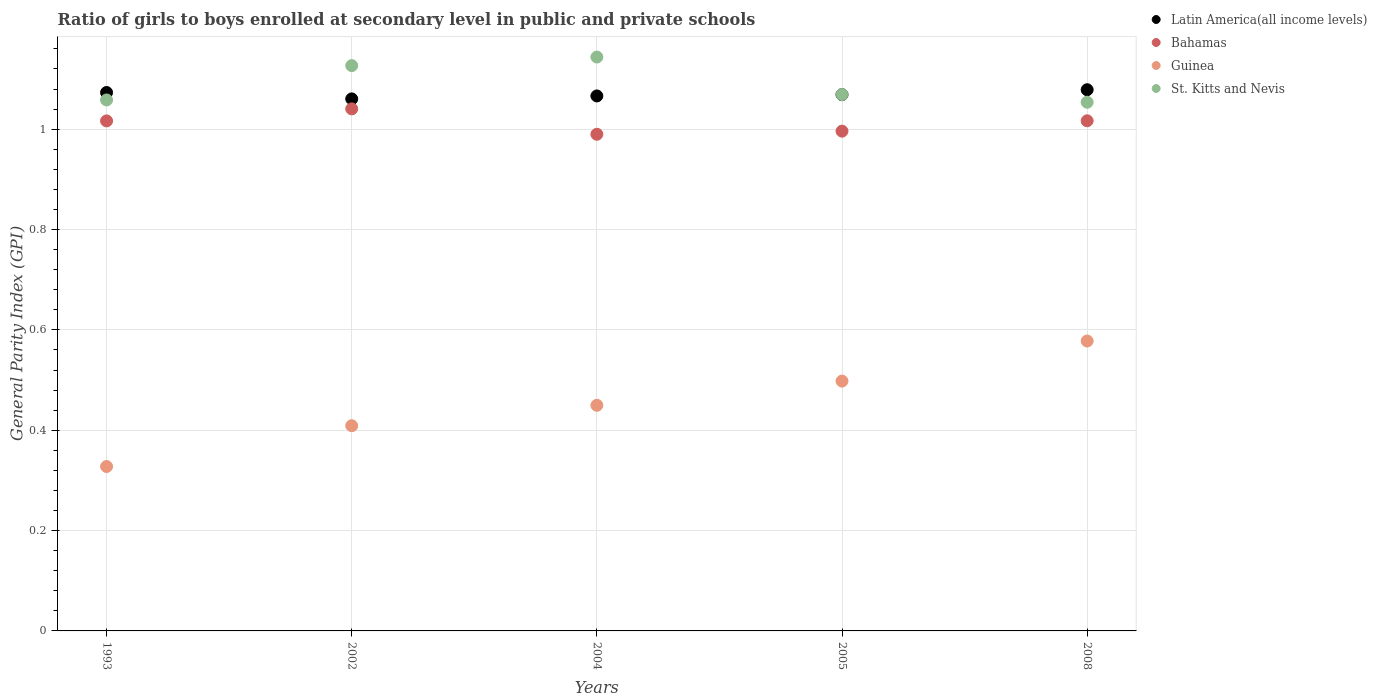How many different coloured dotlines are there?
Provide a succinct answer. 4. What is the general parity index in Latin America(all income levels) in 1993?
Provide a succinct answer. 1.07. Across all years, what is the maximum general parity index in St. Kitts and Nevis?
Give a very brief answer. 1.14. Across all years, what is the minimum general parity index in Guinea?
Make the answer very short. 0.33. In which year was the general parity index in Bahamas minimum?
Give a very brief answer. 2004. What is the total general parity index in Guinea in the graph?
Make the answer very short. 2.26. What is the difference between the general parity index in Latin America(all income levels) in 2004 and that in 2005?
Give a very brief answer. -0. What is the difference between the general parity index in Latin America(all income levels) in 1993 and the general parity index in St. Kitts and Nevis in 2005?
Provide a short and direct response. 0. What is the average general parity index in St. Kitts and Nevis per year?
Offer a very short reply. 1.09. In the year 2008, what is the difference between the general parity index in Bahamas and general parity index in Latin America(all income levels)?
Your response must be concise. -0.06. In how many years, is the general parity index in Latin America(all income levels) greater than 0.92?
Make the answer very short. 5. What is the ratio of the general parity index in St. Kitts and Nevis in 2004 to that in 2008?
Provide a short and direct response. 1.09. What is the difference between the highest and the second highest general parity index in Latin America(all income levels)?
Offer a terse response. 0.01. What is the difference between the highest and the lowest general parity index in Bahamas?
Provide a succinct answer. 0.05. Is it the case that in every year, the sum of the general parity index in St. Kitts and Nevis and general parity index in Guinea  is greater than the sum of general parity index in Bahamas and general parity index in Latin America(all income levels)?
Your answer should be very brief. No. Is it the case that in every year, the sum of the general parity index in Latin America(all income levels) and general parity index in St. Kitts and Nevis  is greater than the general parity index in Guinea?
Provide a succinct answer. Yes. Does the general parity index in Latin America(all income levels) monotonically increase over the years?
Your response must be concise. No. Is the general parity index in St. Kitts and Nevis strictly greater than the general parity index in Bahamas over the years?
Ensure brevity in your answer.  Yes. How many dotlines are there?
Your response must be concise. 4. How many years are there in the graph?
Your response must be concise. 5. Does the graph contain any zero values?
Make the answer very short. No. Does the graph contain grids?
Give a very brief answer. Yes. What is the title of the graph?
Ensure brevity in your answer.  Ratio of girls to boys enrolled at secondary level in public and private schools. What is the label or title of the X-axis?
Your answer should be very brief. Years. What is the label or title of the Y-axis?
Provide a succinct answer. General Parity Index (GPI). What is the General Parity Index (GPI) of Latin America(all income levels) in 1993?
Provide a succinct answer. 1.07. What is the General Parity Index (GPI) in Bahamas in 1993?
Your answer should be very brief. 1.02. What is the General Parity Index (GPI) in Guinea in 1993?
Give a very brief answer. 0.33. What is the General Parity Index (GPI) in St. Kitts and Nevis in 1993?
Provide a succinct answer. 1.06. What is the General Parity Index (GPI) of Latin America(all income levels) in 2002?
Give a very brief answer. 1.06. What is the General Parity Index (GPI) in Bahamas in 2002?
Your response must be concise. 1.04. What is the General Parity Index (GPI) in Guinea in 2002?
Provide a succinct answer. 0.41. What is the General Parity Index (GPI) in St. Kitts and Nevis in 2002?
Your answer should be compact. 1.13. What is the General Parity Index (GPI) in Latin America(all income levels) in 2004?
Provide a short and direct response. 1.07. What is the General Parity Index (GPI) in Bahamas in 2004?
Your answer should be very brief. 0.99. What is the General Parity Index (GPI) in Guinea in 2004?
Make the answer very short. 0.45. What is the General Parity Index (GPI) of St. Kitts and Nevis in 2004?
Your response must be concise. 1.14. What is the General Parity Index (GPI) of Latin America(all income levels) in 2005?
Give a very brief answer. 1.07. What is the General Parity Index (GPI) in Bahamas in 2005?
Provide a succinct answer. 1. What is the General Parity Index (GPI) of Guinea in 2005?
Make the answer very short. 0.5. What is the General Parity Index (GPI) in St. Kitts and Nevis in 2005?
Your response must be concise. 1.07. What is the General Parity Index (GPI) of Latin America(all income levels) in 2008?
Offer a very short reply. 1.08. What is the General Parity Index (GPI) in Bahamas in 2008?
Keep it short and to the point. 1.02. What is the General Parity Index (GPI) of Guinea in 2008?
Your response must be concise. 0.58. What is the General Parity Index (GPI) of St. Kitts and Nevis in 2008?
Keep it short and to the point. 1.05. Across all years, what is the maximum General Parity Index (GPI) in Latin America(all income levels)?
Keep it short and to the point. 1.08. Across all years, what is the maximum General Parity Index (GPI) in Bahamas?
Make the answer very short. 1.04. Across all years, what is the maximum General Parity Index (GPI) in Guinea?
Ensure brevity in your answer.  0.58. Across all years, what is the maximum General Parity Index (GPI) of St. Kitts and Nevis?
Offer a terse response. 1.14. Across all years, what is the minimum General Parity Index (GPI) of Latin America(all income levels)?
Make the answer very short. 1.06. Across all years, what is the minimum General Parity Index (GPI) of Bahamas?
Provide a short and direct response. 0.99. Across all years, what is the minimum General Parity Index (GPI) in Guinea?
Give a very brief answer. 0.33. Across all years, what is the minimum General Parity Index (GPI) in St. Kitts and Nevis?
Make the answer very short. 1.05. What is the total General Parity Index (GPI) in Latin America(all income levels) in the graph?
Offer a very short reply. 5.35. What is the total General Parity Index (GPI) in Bahamas in the graph?
Your response must be concise. 5.06. What is the total General Parity Index (GPI) of Guinea in the graph?
Provide a short and direct response. 2.26. What is the total General Parity Index (GPI) in St. Kitts and Nevis in the graph?
Offer a very short reply. 5.45. What is the difference between the General Parity Index (GPI) in Latin America(all income levels) in 1993 and that in 2002?
Make the answer very short. 0.01. What is the difference between the General Parity Index (GPI) in Bahamas in 1993 and that in 2002?
Make the answer very short. -0.02. What is the difference between the General Parity Index (GPI) of Guinea in 1993 and that in 2002?
Ensure brevity in your answer.  -0.08. What is the difference between the General Parity Index (GPI) in St. Kitts and Nevis in 1993 and that in 2002?
Ensure brevity in your answer.  -0.07. What is the difference between the General Parity Index (GPI) of Latin America(all income levels) in 1993 and that in 2004?
Provide a succinct answer. 0.01. What is the difference between the General Parity Index (GPI) of Bahamas in 1993 and that in 2004?
Your answer should be compact. 0.03. What is the difference between the General Parity Index (GPI) in Guinea in 1993 and that in 2004?
Offer a very short reply. -0.12. What is the difference between the General Parity Index (GPI) in St. Kitts and Nevis in 1993 and that in 2004?
Make the answer very short. -0.09. What is the difference between the General Parity Index (GPI) of Latin America(all income levels) in 1993 and that in 2005?
Your answer should be compact. 0. What is the difference between the General Parity Index (GPI) of Bahamas in 1993 and that in 2005?
Provide a short and direct response. 0.02. What is the difference between the General Parity Index (GPI) of Guinea in 1993 and that in 2005?
Give a very brief answer. -0.17. What is the difference between the General Parity Index (GPI) in St. Kitts and Nevis in 1993 and that in 2005?
Your response must be concise. -0.01. What is the difference between the General Parity Index (GPI) in Latin America(all income levels) in 1993 and that in 2008?
Ensure brevity in your answer.  -0.01. What is the difference between the General Parity Index (GPI) in Bahamas in 1993 and that in 2008?
Provide a succinct answer. -0. What is the difference between the General Parity Index (GPI) of Guinea in 1993 and that in 2008?
Offer a terse response. -0.25. What is the difference between the General Parity Index (GPI) in St. Kitts and Nevis in 1993 and that in 2008?
Offer a very short reply. 0. What is the difference between the General Parity Index (GPI) in Latin America(all income levels) in 2002 and that in 2004?
Keep it short and to the point. -0.01. What is the difference between the General Parity Index (GPI) of Bahamas in 2002 and that in 2004?
Your answer should be compact. 0.05. What is the difference between the General Parity Index (GPI) of Guinea in 2002 and that in 2004?
Your answer should be very brief. -0.04. What is the difference between the General Parity Index (GPI) of St. Kitts and Nevis in 2002 and that in 2004?
Your answer should be compact. -0.02. What is the difference between the General Parity Index (GPI) in Latin America(all income levels) in 2002 and that in 2005?
Keep it short and to the point. -0.01. What is the difference between the General Parity Index (GPI) in Bahamas in 2002 and that in 2005?
Ensure brevity in your answer.  0.04. What is the difference between the General Parity Index (GPI) in Guinea in 2002 and that in 2005?
Ensure brevity in your answer.  -0.09. What is the difference between the General Parity Index (GPI) in St. Kitts and Nevis in 2002 and that in 2005?
Your answer should be compact. 0.06. What is the difference between the General Parity Index (GPI) of Latin America(all income levels) in 2002 and that in 2008?
Your answer should be compact. -0.02. What is the difference between the General Parity Index (GPI) in Bahamas in 2002 and that in 2008?
Offer a very short reply. 0.02. What is the difference between the General Parity Index (GPI) of Guinea in 2002 and that in 2008?
Your answer should be very brief. -0.17. What is the difference between the General Parity Index (GPI) in St. Kitts and Nevis in 2002 and that in 2008?
Provide a succinct answer. 0.07. What is the difference between the General Parity Index (GPI) in Latin America(all income levels) in 2004 and that in 2005?
Give a very brief answer. -0. What is the difference between the General Parity Index (GPI) in Bahamas in 2004 and that in 2005?
Your answer should be very brief. -0.01. What is the difference between the General Parity Index (GPI) in Guinea in 2004 and that in 2005?
Your answer should be very brief. -0.05. What is the difference between the General Parity Index (GPI) of St. Kitts and Nevis in 2004 and that in 2005?
Ensure brevity in your answer.  0.07. What is the difference between the General Parity Index (GPI) of Latin America(all income levels) in 2004 and that in 2008?
Your answer should be compact. -0.01. What is the difference between the General Parity Index (GPI) in Bahamas in 2004 and that in 2008?
Keep it short and to the point. -0.03. What is the difference between the General Parity Index (GPI) in Guinea in 2004 and that in 2008?
Your answer should be very brief. -0.13. What is the difference between the General Parity Index (GPI) of St. Kitts and Nevis in 2004 and that in 2008?
Offer a very short reply. 0.09. What is the difference between the General Parity Index (GPI) of Latin America(all income levels) in 2005 and that in 2008?
Give a very brief answer. -0.01. What is the difference between the General Parity Index (GPI) of Bahamas in 2005 and that in 2008?
Offer a terse response. -0.02. What is the difference between the General Parity Index (GPI) in Guinea in 2005 and that in 2008?
Your response must be concise. -0.08. What is the difference between the General Parity Index (GPI) of St. Kitts and Nevis in 2005 and that in 2008?
Provide a succinct answer. 0.02. What is the difference between the General Parity Index (GPI) of Latin America(all income levels) in 1993 and the General Parity Index (GPI) of Bahamas in 2002?
Your answer should be very brief. 0.03. What is the difference between the General Parity Index (GPI) in Latin America(all income levels) in 1993 and the General Parity Index (GPI) in Guinea in 2002?
Provide a succinct answer. 0.66. What is the difference between the General Parity Index (GPI) of Latin America(all income levels) in 1993 and the General Parity Index (GPI) of St. Kitts and Nevis in 2002?
Offer a terse response. -0.05. What is the difference between the General Parity Index (GPI) of Bahamas in 1993 and the General Parity Index (GPI) of Guinea in 2002?
Your answer should be very brief. 0.61. What is the difference between the General Parity Index (GPI) in Bahamas in 1993 and the General Parity Index (GPI) in St. Kitts and Nevis in 2002?
Your answer should be compact. -0.11. What is the difference between the General Parity Index (GPI) in Guinea in 1993 and the General Parity Index (GPI) in St. Kitts and Nevis in 2002?
Make the answer very short. -0.8. What is the difference between the General Parity Index (GPI) of Latin America(all income levels) in 1993 and the General Parity Index (GPI) of Bahamas in 2004?
Your response must be concise. 0.08. What is the difference between the General Parity Index (GPI) in Latin America(all income levels) in 1993 and the General Parity Index (GPI) in Guinea in 2004?
Your answer should be compact. 0.62. What is the difference between the General Parity Index (GPI) of Latin America(all income levels) in 1993 and the General Parity Index (GPI) of St. Kitts and Nevis in 2004?
Ensure brevity in your answer.  -0.07. What is the difference between the General Parity Index (GPI) of Bahamas in 1993 and the General Parity Index (GPI) of Guinea in 2004?
Give a very brief answer. 0.57. What is the difference between the General Parity Index (GPI) in Bahamas in 1993 and the General Parity Index (GPI) in St. Kitts and Nevis in 2004?
Offer a terse response. -0.13. What is the difference between the General Parity Index (GPI) of Guinea in 1993 and the General Parity Index (GPI) of St. Kitts and Nevis in 2004?
Offer a very short reply. -0.82. What is the difference between the General Parity Index (GPI) in Latin America(all income levels) in 1993 and the General Parity Index (GPI) in Bahamas in 2005?
Provide a succinct answer. 0.08. What is the difference between the General Parity Index (GPI) of Latin America(all income levels) in 1993 and the General Parity Index (GPI) of Guinea in 2005?
Ensure brevity in your answer.  0.58. What is the difference between the General Parity Index (GPI) in Latin America(all income levels) in 1993 and the General Parity Index (GPI) in St. Kitts and Nevis in 2005?
Keep it short and to the point. 0. What is the difference between the General Parity Index (GPI) of Bahamas in 1993 and the General Parity Index (GPI) of Guinea in 2005?
Provide a short and direct response. 0.52. What is the difference between the General Parity Index (GPI) of Bahamas in 1993 and the General Parity Index (GPI) of St. Kitts and Nevis in 2005?
Make the answer very short. -0.05. What is the difference between the General Parity Index (GPI) of Guinea in 1993 and the General Parity Index (GPI) of St. Kitts and Nevis in 2005?
Make the answer very short. -0.74. What is the difference between the General Parity Index (GPI) in Latin America(all income levels) in 1993 and the General Parity Index (GPI) in Bahamas in 2008?
Keep it short and to the point. 0.06. What is the difference between the General Parity Index (GPI) of Latin America(all income levels) in 1993 and the General Parity Index (GPI) of Guinea in 2008?
Give a very brief answer. 0.5. What is the difference between the General Parity Index (GPI) in Latin America(all income levels) in 1993 and the General Parity Index (GPI) in St. Kitts and Nevis in 2008?
Ensure brevity in your answer.  0.02. What is the difference between the General Parity Index (GPI) in Bahamas in 1993 and the General Parity Index (GPI) in Guinea in 2008?
Provide a short and direct response. 0.44. What is the difference between the General Parity Index (GPI) in Bahamas in 1993 and the General Parity Index (GPI) in St. Kitts and Nevis in 2008?
Provide a succinct answer. -0.04. What is the difference between the General Parity Index (GPI) in Guinea in 1993 and the General Parity Index (GPI) in St. Kitts and Nevis in 2008?
Give a very brief answer. -0.73. What is the difference between the General Parity Index (GPI) in Latin America(all income levels) in 2002 and the General Parity Index (GPI) in Bahamas in 2004?
Ensure brevity in your answer.  0.07. What is the difference between the General Parity Index (GPI) in Latin America(all income levels) in 2002 and the General Parity Index (GPI) in Guinea in 2004?
Provide a short and direct response. 0.61. What is the difference between the General Parity Index (GPI) of Latin America(all income levels) in 2002 and the General Parity Index (GPI) of St. Kitts and Nevis in 2004?
Keep it short and to the point. -0.08. What is the difference between the General Parity Index (GPI) of Bahamas in 2002 and the General Parity Index (GPI) of Guinea in 2004?
Provide a short and direct response. 0.59. What is the difference between the General Parity Index (GPI) of Bahamas in 2002 and the General Parity Index (GPI) of St. Kitts and Nevis in 2004?
Your answer should be compact. -0.1. What is the difference between the General Parity Index (GPI) in Guinea in 2002 and the General Parity Index (GPI) in St. Kitts and Nevis in 2004?
Your response must be concise. -0.73. What is the difference between the General Parity Index (GPI) in Latin America(all income levels) in 2002 and the General Parity Index (GPI) in Bahamas in 2005?
Keep it short and to the point. 0.06. What is the difference between the General Parity Index (GPI) of Latin America(all income levels) in 2002 and the General Parity Index (GPI) of Guinea in 2005?
Keep it short and to the point. 0.56. What is the difference between the General Parity Index (GPI) of Latin America(all income levels) in 2002 and the General Parity Index (GPI) of St. Kitts and Nevis in 2005?
Provide a succinct answer. -0.01. What is the difference between the General Parity Index (GPI) in Bahamas in 2002 and the General Parity Index (GPI) in Guinea in 2005?
Give a very brief answer. 0.54. What is the difference between the General Parity Index (GPI) in Bahamas in 2002 and the General Parity Index (GPI) in St. Kitts and Nevis in 2005?
Keep it short and to the point. -0.03. What is the difference between the General Parity Index (GPI) of Guinea in 2002 and the General Parity Index (GPI) of St. Kitts and Nevis in 2005?
Make the answer very short. -0.66. What is the difference between the General Parity Index (GPI) of Latin America(all income levels) in 2002 and the General Parity Index (GPI) of Bahamas in 2008?
Provide a short and direct response. 0.04. What is the difference between the General Parity Index (GPI) in Latin America(all income levels) in 2002 and the General Parity Index (GPI) in Guinea in 2008?
Offer a very short reply. 0.48. What is the difference between the General Parity Index (GPI) in Latin America(all income levels) in 2002 and the General Parity Index (GPI) in St. Kitts and Nevis in 2008?
Your response must be concise. 0.01. What is the difference between the General Parity Index (GPI) of Bahamas in 2002 and the General Parity Index (GPI) of Guinea in 2008?
Make the answer very short. 0.46. What is the difference between the General Parity Index (GPI) in Bahamas in 2002 and the General Parity Index (GPI) in St. Kitts and Nevis in 2008?
Give a very brief answer. -0.01. What is the difference between the General Parity Index (GPI) in Guinea in 2002 and the General Parity Index (GPI) in St. Kitts and Nevis in 2008?
Give a very brief answer. -0.64. What is the difference between the General Parity Index (GPI) in Latin America(all income levels) in 2004 and the General Parity Index (GPI) in Bahamas in 2005?
Provide a succinct answer. 0.07. What is the difference between the General Parity Index (GPI) of Latin America(all income levels) in 2004 and the General Parity Index (GPI) of Guinea in 2005?
Offer a terse response. 0.57. What is the difference between the General Parity Index (GPI) of Latin America(all income levels) in 2004 and the General Parity Index (GPI) of St. Kitts and Nevis in 2005?
Ensure brevity in your answer.  -0. What is the difference between the General Parity Index (GPI) of Bahamas in 2004 and the General Parity Index (GPI) of Guinea in 2005?
Provide a short and direct response. 0.49. What is the difference between the General Parity Index (GPI) in Bahamas in 2004 and the General Parity Index (GPI) in St. Kitts and Nevis in 2005?
Provide a short and direct response. -0.08. What is the difference between the General Parity Index (GPI) in Guinea in 2004 and the General Parity Index (GPI) in St. Kitts and Nevis in 2005?
Offer a terse response. -0.62. What is the difference between the General Parity Index (GPI) of Latin America(all income levels) in 2004 and the General Parity Index (GPI) of Bahamas in 2008?
Your response must be concise. 0.05. What is the difference between the General Parity Index (GPI) in Latin America(all income levels) in 2004 and the General Parity Index (GPI) in Guinea in 2008?
Provide a short and direct response. 0.49. What is the difference between the General Parity Index (GPI) in Latin America(all income levels) in 2004 and the General Parity Index (GPI) in St. Kitts and Nevis in 2008?
Give a very brief answer. 0.01. What is the difference between the General Parity Index (GPI) of Bahamas in 2004 and the General Parity Index (GPI) of Guinea in 2008?
Your answer should be very brief. 0.41. What is the difference between the General Parity Index (GPI) of Bahamas in 2004 and the General Parity Index (GPI) of St. Kitts and Nevis in 2008?
Provide a short and direct response. -0.06. What is the difference between the General Parity Index (GPI) of Guinea in 2004 and the General Parity Index (GPI) of St. Kitts and Nevis in 2008?
Provide a succinct answer. -0.6. What is the difference between the General Parity Index (GPI) of Latin America(all income levels) in 2005 and the General Parity Index (GPI) of Bahamas in 2008?
Your response must be concise. 0.05. What is the difference between the General Parity Index (GPI) of Latin America(all income levels) in 2005 and the General Parity Index (GPI) of Guinea in 2008?
Keep it short and to the point. 0.49. What is the difference between the General Parity Index (GPI) of Latin America(all income levels) in 2005 and the General Parity Index (GPI) of St. Kitts and Nevis in 2008?
Your answer should be very brief. 0.02. What is the difference between the General Parity Index (GPI) in Bahamas in 2005 and the General Parity Index (GPI) in Guinea in 2008?
Provide a succinct answer. 0.42. What is the difference between the General Parity Index (GPI) in Bahamas in 2005 and the General Parity Index (GPI) in St. Kitts and Nevis in 2008?
Provide a succinct answer. -0.06. What is the difference between the General Parity Index (GPI) of Guinea in 2005 and the General Parity Index (GPI) of St. Kitts and Nevis in 2008?
Your answer should be compact. -0.56. What is the average General Parity Index (GPI) of Latin America(all income levels) per year?
Ensure brevity in your answer.  1.07. What is the average General Parity Index (GPI) in Bahamas per year?
Ensure brevity in your answer.  1.01. What is the average General Parity Index (GPI) in Guinea per year?
Your answer should be compact. 0.45. What is the average General Parity Index (GPI) in St. Kitts and Nevis per year?
Offer a very short reply. 1.09. In the year 1993, what is the difference between the General Parity Index (GPI) of Latin America(all income levels) and General Parity Index (GPI) of Bahamas?
Keep it short and to the point. 0.06. In the year 1993, what is the difference between the General Parity Index (GPI) in Latin America(all income levels) and General Parity Index (GPI) in Guinea?
Give a very brief answer. 0.75. In the year 1993, what is the difference between the General Parity Index (GPI) in Latin America(all income levels) and General Parity Index (GPI) in St. Kitts and Nevis?
Your answer should be very brief. 0.01. In the year 1993, what is the difference between the General Parity Index (GPI) of Bahamas and General Parity Index (GPI) of Guinea?
Provide a short and direct response. 0.69. In the year 1993, what is the difference between the General Parity Index (GPI) of Bahamas and General Parity Index (GPI) of St. Kitts and Nevis?
Make the answer very short. -0.04. In the year 1993, what is the difference between the General Parity Index (GPI) of Guinea and General Parity Index (GPI) of St. Kitts and Nevis?
Your answer should be compact. -0.73. In the year 2002, what is the difference between the General Parity Index (GPI) in Latin America(all income levels) and General Parity Index (GPI) in Bahamas?
Keep it short and to the point. 0.02. In the year 2002, what is the difference between the General Parity Index (GPI) in Latin America(all income levels) and General Parity Index (GPI) in Guinea?
Your response must be concise. 0.65. In the year 2002, what is the difference between the General Parity Index (GPI) of Latin America(all income levels) and General Parity Index (GPI) of St. Kitts and Nevis?
Offer a terse response. -0.07. In the year 2002, what is the difference between the General Parity Index (GPI) of Bahamas and General Parity Index (GPI) of Guinea?
Offer a terse response. 0.63. In the year 2002, what is the difference between the General Parity Index (GPI) in Bahamas and General Parity Index (GPI) in St. Kitts and Nevis?
Make the answer very short. -0.09. In the year 2002, what is the difference between the General Parity Index (GPI) in Guinea and General Parity Index (GPI) in St. Kitts and Nevis?
Give a very brief answer. -0.72. In the year 2004, what is the difference between the General Parity Index (GPI) of Latin America(all income levels) and General Parity Index (GPI) of Bahamas?
Offer a terse response. 0.08. In the year 2004, what is the difference between the General Parity Index (GPI) in Latin America(all income levels) and General Parity Index (GPI) in Guinea?
Your response must be concise. 0.62. In the year 2004, what is the difference between the General Parity Index (GPI) of Latin America(all income levels) and General Parity Index (GPI) of St. Kitts and Nevis?
Offer a very short reply. -0.08. In the year 2004, what is the difference between the General Parity Index (GPI) in Bahamas and General Parity Index (GPI) in Guinea?
Make the answer very short. 0.54. In the year 2004, what is the difference between the General Parity Index (GPI) in Bahamas and General Parity Index (GPI) in St. Kitts and Nevis?
Your response must be concise. -0.15. In the year 2004, what is the difference between the General Parity Index (GPI) of Guinea and General Parity Index (GPI) of St. Kitts and Nevis?
Your answer should be compact. -0.69. In the year 2005, what is the difference between the General Parity Index (GPI) in Latin America(all income levels) and General Parity Index (GPI) in Bahamas?
Keep it short and to the point. 0.07. In the year 2005, what is the difference between the General Parity Index (GPI) in Latin America(all income levels) and General Parity Index (GPI) in Guinea?
Ensure brevity in your answer.  0.57. In the year 2005, what is the difference between the General Parity Index (GPI) of Latin America(all income levels) and General Parity Index (GPI) of St. Kitts and Nevis?
Provide a succinct answer. -0. In the year 2005, what is the difference between the General Parity Index (GPI) of Bahamas and General Parity Index (GPI) of Guinea?
Offer a terse response. 0.5. In the year 2005, what is the difference between the General Parity Index (GPI) of Bahamas and General Parity Index (GPI) of St. Kitts and Nevis?
Provide a short and direct response. -0.07. In the year 2005, what is the difference between the General Parity Index (GPI) in Guinea and General Parity Index (GPI) in St. Kitts and Nevis?
Your response must be concise. -0.57. In the year 2008, what is the difference between the General Parity Index (GPI) of Latin America(all income levels) and General Parity Index (GPI) of Bahamas?
Offer a terse response. 0.06. In the year 2008, what is the difference between the General Parity Index (GPI) of Latin America(all income levels) and General Parity Index (GPI) of Guinea?
Ensure brevity in your answer.  0.5. In the year 2008, what is the difference between the General Parity Index (GPI) in Latin America(all income levels) and General Parity Index (GPI) in St. Kitts and Nevis?
Make the answer very short. 0.03. In the year 2008, what is the difference between the General Parity Index (GPI) of Bahamas and General Parity Index (GPI) of Guinea?
Your answer should be compact. 0.44. In the year 2008, what is the difference between the General Parity Index (GPI) in Bahamas and General Parity Index (GPI) in St. Kitts and Nevis?
Keep it short and to the point. -0.04. In the year 2008, what is the difference between the General Parity Index (GPI) of Guinea and General Parity Index (GPI) of St. Kitts and Nevis?
Your response must be concise. -0.48. What is the ratio of the General Parity Index (GPI) of Latin America(all income levels) in 1993 to that in 2002?
Provide a succinct answer. 1.01. What is the ratio of the General Parity Index (GPI) of Bahamas in 1993 to that in 2002?
Your answer should be very brief. 0.98. What is the ratio of the General Parity Index (GPI) of Guinea in 1993 to that in 2002?
Offer a terse response. 0.8. What is the ratio of the General Parity Index (GPI) of St. Kitts and Nevis in 1993 to that in 2002?
Provide a short and direct response. 0.94. What is the ratio of the General Parity Index (GPI) of Latin America(all income levels) in 1993 to that in 2004?
Keep it short and to the point. 1.01. What is the ratio of the General Parity Index (GPI) of Bahamas in 1993 to that in 2004?
Your answer should be compact. 1.03. What is the ratio of the General Parity Index (GPI) of Guinea in 1993 to that in 2004?
Ensure brevity in your answer.  0.73. What is the ratio of the General Parity Index (GPI) of St. Kitts and Nevis in 1993 to that in 2004?
Keep it short and to the point. 0.93. What is the ratio of the General Parity Index (GPI) of Bahamas in 1993 to that in 2005?
Your answer should be very brief. 1.02. What is the ratio of the General Parity Index (GPI) in Guinea in 1993 to that in 2005?
Your answer should be compact. 0.66. What is the ratio of the General Parity Index (GPI) in Bahamas in 1993 to that in 2008?
Your answer should be compact. 1. What is the ratio of the General Parity Index (GPI) in Guinea in 1993 to that in 2008?
Ensure brevity in your answer.  0.57. What is the ratio of the General Parity Index (GPI) in Latin America(all income levels) in 2002 to that in 2004?
Provide a short and direct response. 0.99. What is the ratio of the General Parity Index (GPI) of Bahamas in 2002 to that in 2004?
Your response must be concise. 1.05. What is the ratio of the General Parity Index (GPI) of Guinea in 2002 to that in 2004?
Make the answer very short. 0.91. What is the ratio of the General Parity Index (GPI) in Bahamas in 2002 to that in 2005?
Keep it short and to the point. 1.04. What is the ratio of the General Parity Index (GPI) of Guinea in 2002 to that in 2005?
Offer a very short reply. 0.82. What is the ratio of the General Parity Index (GPI) in St. Kitts and Nevis in 2002 to that in 2005?
Your answer should be very brief. 1.05. What is the ratio of the General Parity Index (GPI) of Latin America(all income levels) in 2002 to that in 2008?
Provide a short and direct response. 0.98. What is the ratio of the General Parity Index (GPI) of Bahamas in 2002 to that in 2008?
Provide a succinct answer. 1.02. What is the ratio of the General Parity Index (GPI) of Guinea in 2002 to that in 2008?
Ensure brevity in your answer.  0.71. What is the ratio of the General Parity Index (GPI) of St. Kitts and Nevis in 2002 to that in 2008?
Give a very brief answer. 1.07. What is the ratio of the General Parity Index (GPI) of Latin America(all income levels) in 2004 to that in 2005?
Your answer should be very brief. 1. What is the ratio of the General Parity Index (GPI) in Guinea in 2004 to that in 2005?
Keep it short and to the point. 0.9. What is the ratio of the General Parity Index (GPI) in St. Kitts and Nevis in 2004 to that in 2005?
Ensure brevity in your answer.  1.07. What is the ratio of the General Parity Index (GPI) in Bahamas in 2004 to that in 2008?
Offer a very short reply. 0.97. What is the ratio of the General Parity Index (GPI) of Guinea in 2004 to that in 2008?
Ensure brevity in your answer.  0.78. What is the ratio of the General Parity Index (GPI) in St. Kitts and Nevis in 2004 to that in 2008?
Give a very brief answer. 1.09. What is the ratio of the General Parity Index (GPI) in Latin America(all income levels) in 2005 to that in 2008?
Ensure brevity in your answer.  0.99. What is the ratio of the General Parity Index (GPI) of Bahamas in 2005 to that in 2008?
Your answer should be compact. 0.98. What is the ratio of the General Parity Index (GPI) of Guinea in 2005 to that in 2008?
Provide a succinct answer. 0.86. What is the ratio of the General Parity Index (GPI) of St. Kitts and Nevis in 2005 to that in 2008?
Provide a short and direct response. 1.01. What is the difference between the highest and the second highest General Parity Index (GPI) in Latin America(all income levels)?
Offer a very short reply. 0.01. What is the difference between the highest and the second highest General Parity Index (GPI) in Bahamas?
Ensure brevity in your answer.  0.02. What is the difference between the highest and the second highest General Parity Index (GPI) of Guinea?
Keep it short and to the point. 0.08. What is the difference between the highest and the second highest General Parity Index (GPI) of St. Kitts and Nevis?
Offer a terse response. 0.02. What is the difference between the highest and the lowest General Parity Index (GPI) of Latin America(all income levels)?
Keep it short and to the point. 0.02. What is the difference between the highest and the lowest General Parity Index (GPI) of Bahamas?
Ensure brevity in your answer.  0.05. What is the difference between the highest and the lowest General Parity Index (GPI) of Guinea?
Offer a very short reply. 0.25. What is the difference between the highest and the lowest General Parity Index (GPI) of St. Kitts and Nevis?
Ensure brevity in your answer.  0.09. 